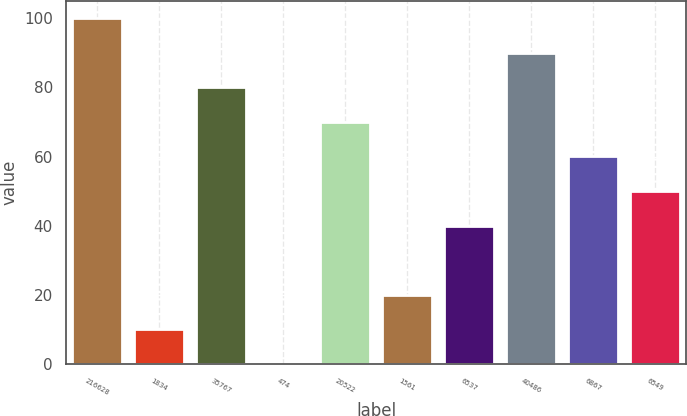Convert chart. <chart><loc_0><loc_0><loc_500><loc_500><bar_chart><fcel>216628<fcel>1834<fcel>35767<fcel>474<fcel>20522<fcel>1561<fcel>6537<fcel>40486<fcel>6867<fcel>6549<nl><fcel>100<fcel>10.09<fcel>80.02<fcel>0.1<fcel>70.03<fcel>20.08<fcel>40.06<fcel>90.01<fcel>60.04<fcel>50.05<nl></chart> 